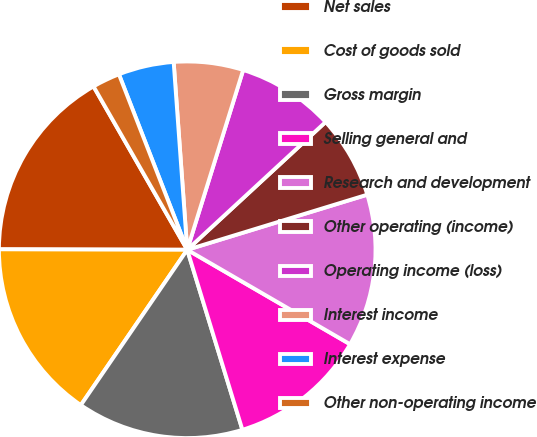Convert chart. <chart><loc_0><loc_0><loc_500><loc_500><pie_chart><fcel>Net sales<fcel>Cost of goods sold<fcel>Gross margin<fcel>Selling general and<fcel>Research and development<fcel>Other operating (income)<fcel>Operating income (loss)<fcel>Interest income<fcel>Interest expense<fcel>Other non-operating income<nl><fcel>16.67%<fcel>15.48%<fcel>14.29%<fcel>11.9%<fcel>13.09%<fcel>7.14%<fcel>8.33%<fcel>5.95%<fcel>4.76%<fcel>2.38%<nl></chart> 